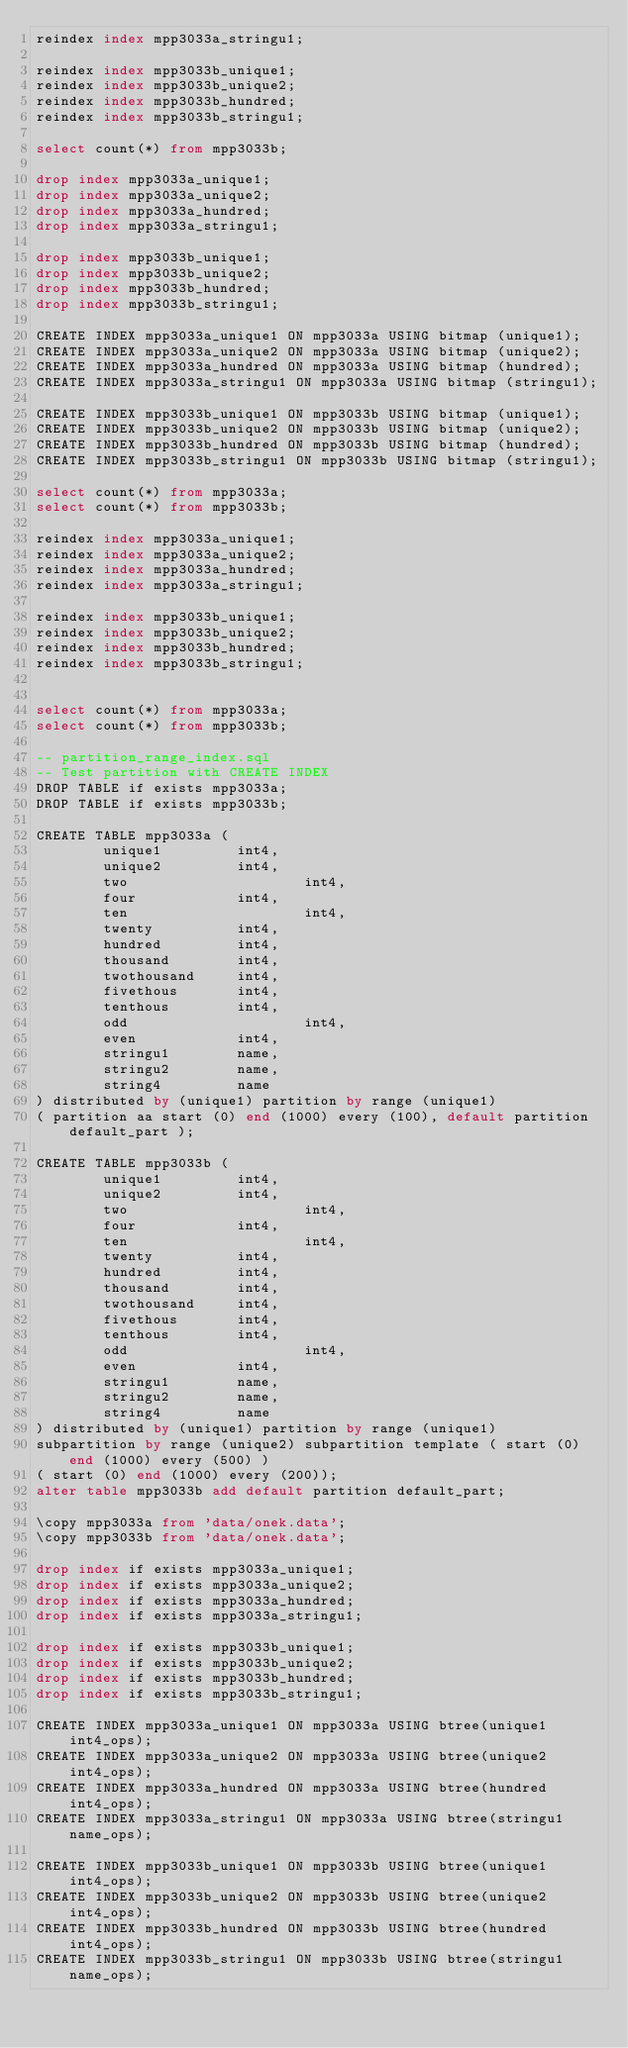Convert code to text. <code><loc_0><loc_0><loc_500><loc_500><_SQL_>reindex index mpp3033a_stringu1;

reindex index mpp3033b_unique1;
reindex index mpp3033b_unique2;
reindex index mpp3033b_hundred;
reindex index mpp3033b_stringu1;

select count(*) from mpp3033b;

drop index mpp3033a_unique1;
drop index mpp3033a_unique2;
drop index mpp3033a_hundred;
drop index mpp3033a_stringu1;

drop index mpp3033b_unique1;
drop index mpp3033b_unique2;
drop index mpp3033b_hundred;
drop index mpp3033b_stringu1;

CREATE INDEX mpp3033a_unique1 ON mpp3033a USING bitmap (unique1);
CREATE INDEX mpp3033a_unique2 ON mpp3033a USING bitmap (unique2);
CREATE INDEX mpp3033a_hundred ON mpp3033a USING bitmap (hundred);
CREATE INDEX mpp3033a_stringu1 ON mpp3033a USING bitmap (stringu1);

CREATE INDEX mpp3033b_unique1 ON mpp3033b USING bitmap (unique1);
CREATE INDEX mpp3033b_unique2 ON mpp3033b USING bitmap (unique2);
CREATE INDEX mpp3033b_hundred ON mpp3033b USING bitmap (hundred);
CREATE INDEX mpp3033b_stringu1 ON mpp3033b USING bitmap (stringu1);

select count(*) from mpp3033a;
select count(*) from mpp3033b;

reindex index mpp3033a_unique1;
reindex index mpp3033a_unique2;
reindex index mpp3033a_hundred;
reindex index mpp3033a_stringu1;

reindex index mpp3033b_unique1;
reindex index mpp3033b_unique2;
reindex index mpp3033b_hundred;
reindex index mpp3033b_stringu1;


select count(*) from mpp3033a;
select count(*) from mpp3033b;

-- partition_range_index.sql
-- Test partition with CREATE INDEX
DROP TABLE if exists mpp3033a;
DROP TABLE if exists mpp3033b;

CREATE TABLE mpp3033a (
        unique1         int4,
        unique2         int4,
        two                     int4,
        four            int4,
        ten                     int4,
        twenty          int4,
        hundred         int4,
        thousand        int4,
        twothousand     int4,
        fivethous       int4,
        tenthous        int4,
        odd                     int4,
        even            int4,
        stringu1        name,
        stringu2        name,
        string4         name
) distributed by (unique1) partition by range (unique1)
( partition aa start (0) end (1000) every (100), default partition default_part );

CREATE TABLE mpp3033b (
        unique1         int4,
        unique2         int4,
        two                     int4,
        four            int4,
        ten                     int4,
        twenty          int4,
        hundred         int4,
        thousand        int4,
        twothousand     int4,
        fivethous       int4,
        tenthous        int4,
        odd                     int4,
        even            int4,
        stringu1        name,
        stringu2        name,
        string4         name
) distributed by (unique1) partition by range (unique1)
subpartition by range (unique2) subpartition template ( start (0) end (1000) every (500) )
( start (0) end (1000) every (200));
alter table mpp3033b add default partition default_part;

\copy mpp3033a from 'data/onek.data';
\copy mpp3033b from 'data/onek.data';

drop index if exists mpp3033a_unique1;
drop index if exists mpp3033a_unique2;
drop index if exists mpp3033a_hundred;
drop index if exists mpp3033a_stringu1;

drop index if exists mpp3033b_unique1;
drop index if exists mpp3033b_unique2;
drop index if exists mpp3033b_hundred;
drop index if exists mpp3033b_stringu1;

CREATE INDEX mpp3033a_unique1 ON mpp3033a USING btree(unique1 int4_ops);
CREATE INDEX mpp3033a_unique2 ON mpp3033a USING btree(unique2 int4_ops);
CREATE INDEX mpp3033a_hundred ON mpp3033a USING btree(hundred int4_ops);
CREATE INDEX mpp3033a_stringu1 ON mpp3033a USING btree(stringu1 name_ops);

CREATE INDEX mpp3033b_unique1 ON mpp3033b USING btree(unique1 int4_ops);
CREATE INDEX mpp3033b_unique2 ON mpp3033b USING btree(unique2 int4_ops);
CREATE INDEX mpp3033b_hundred ON mpp3033b USING btree(hundred int4_ops);
CREATE INDEX mpp3033b_stringu1 ON mpp3033b USING btree(stringu1 name_ops);

</code> 